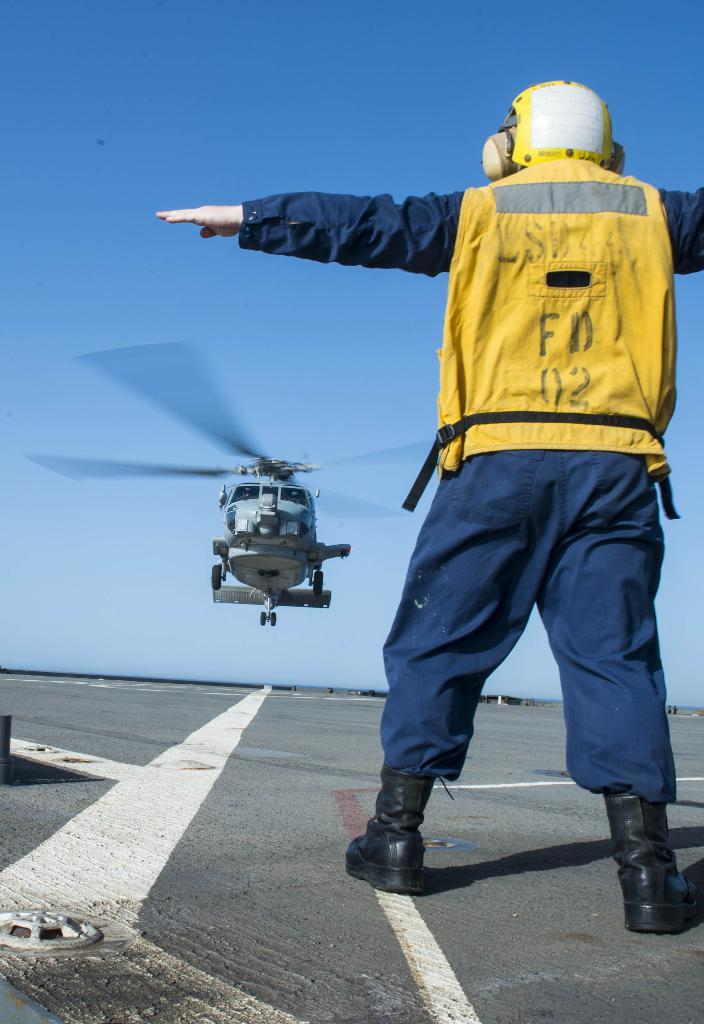<image>
Share a concise interpretation of the image provided. A helicopter director labeled FD 02 directs a chopper in landing. 